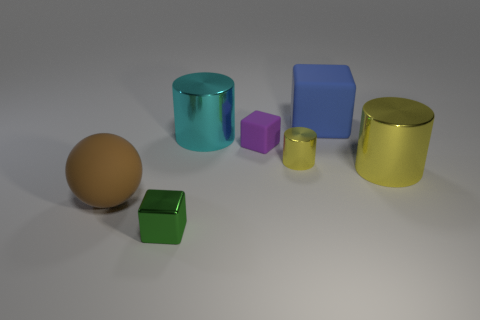Can you describe the materials and textures of the objects shown? Certainly! The objects displayed exhibit a variety of materials with corresponding textures. The sphere and the cylinders have a shiny, metallic sheen suggesting they are made of polished metal. The cubes, however, appear matte, indicating a possible plastic or painted wood finish, although a closer inspection is needed for precision. 